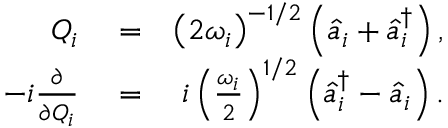Convert formula to latex. <formula><loc_0><loc_0><loc_500><loc_500>\begin{array} { r l r } { Q _ { i } } & = } & { \left ( 2 \omega _ { i } \right ) ^ { - 1 / 2 } \left ( \hat { a } _ { i } + \hat { a } _ { i } ^ { \dagger } \right ) , } \\ { - i \frac { \partial } { \partial Q _ { i } } } & = } & { i \left ( \frac { \omega _ { i } } { 2 } \right ) ^ { 1 / 2 } \left ( \hat { a } _ { i } ^ { \dagger } - \hat { a } _ { i } \right ) . } \end{array}</formula> 